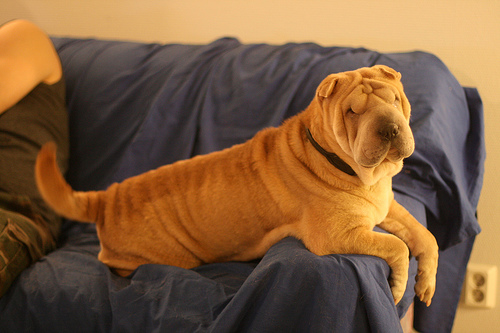What breed is the dog pictured? The dog is a Shar Pei, known for its distinctive wrinkly skin and a somewhat solemn yet charming expression. 